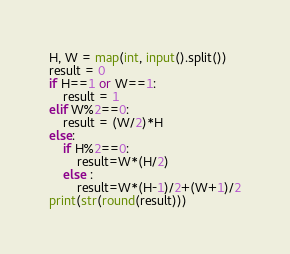Convert code to text. <code><loc_0><loc_0><loc_500><loc_500><_Python_>H, W = map(int, input().split())
result = 0
if H==1 or W==1:
    result = 1
elif W%2==0:
    result = (W/2)*H
else:
    if H%2==0:
        result=W*(H/2)
    else :
        result=W*(H-1)/2+(W+1)/2
print(str(round(result)))
</code> 